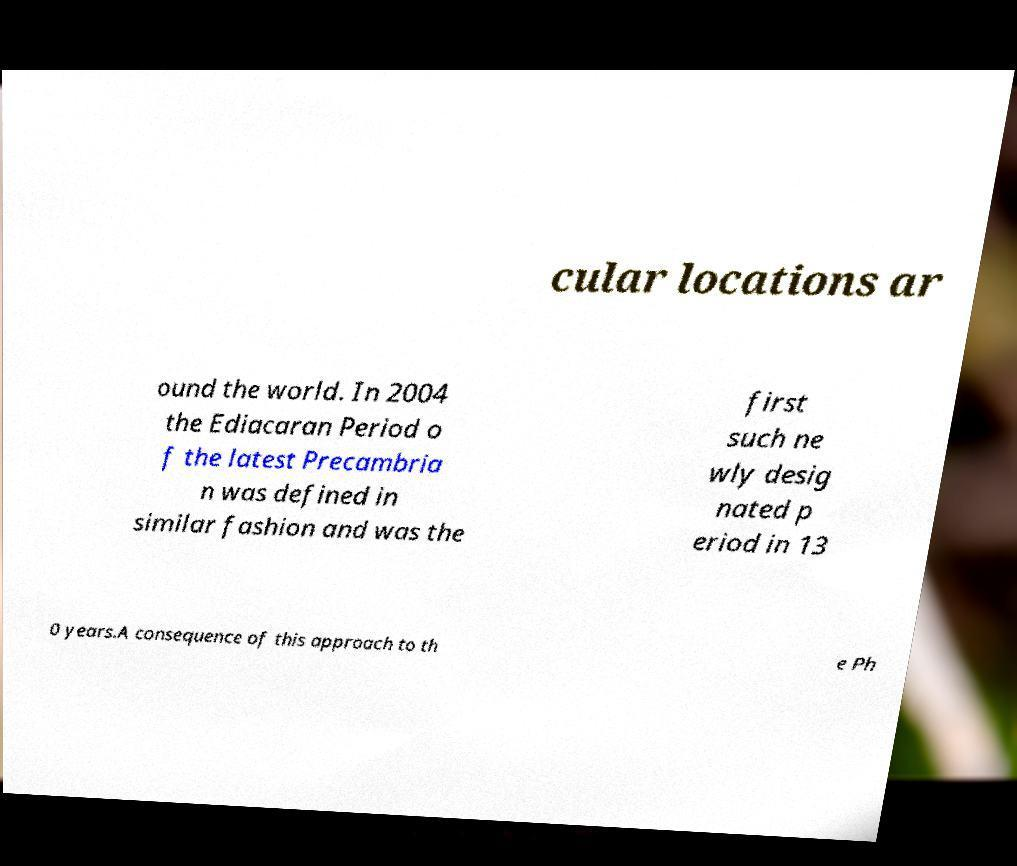I need the written content from this picture converted into text. Can you do that? cular locations ar ound the world. In 2004 the Ediacaran Period o f the latest Precambria n was defined in similar fashion and was the first such ne wly desig nated p eriod in 13 0 years.A consequence of this approach to th e Ph 